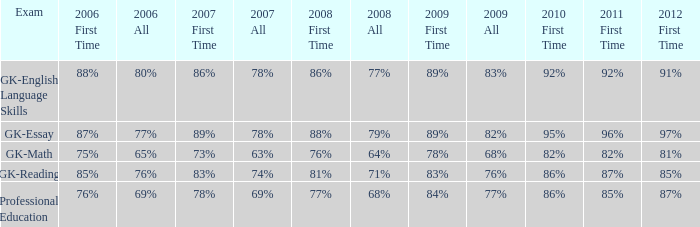What is the fraction for all in 2008 when all in 2007 was 69%? 68%. 